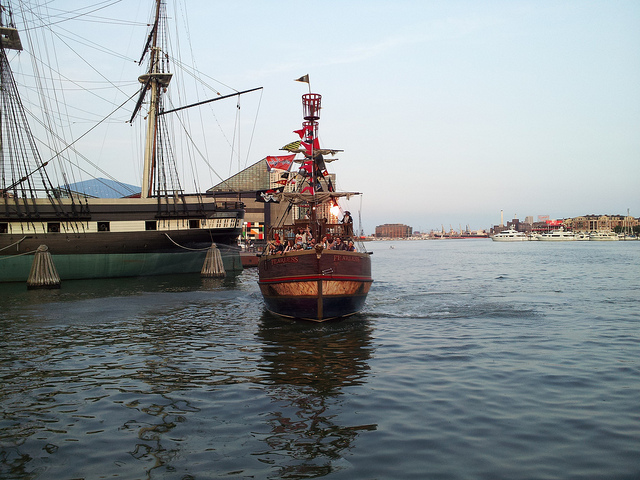<image>What country is this boat from? I don't know the country of this boat. It can be from USA, Sweden, England, China, or Spain. What country is this boat from? I don't know what country this boat is from. It can be from USA, Sweden, England, China, or Spain. 